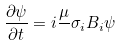<formula> <loc_0><loc_0><loc_500><loc_500>\frac { \partial \psi } { \partial t } = i \frac { \mu } { } \sigma _ { i } B _ { i } \psi</formula> 